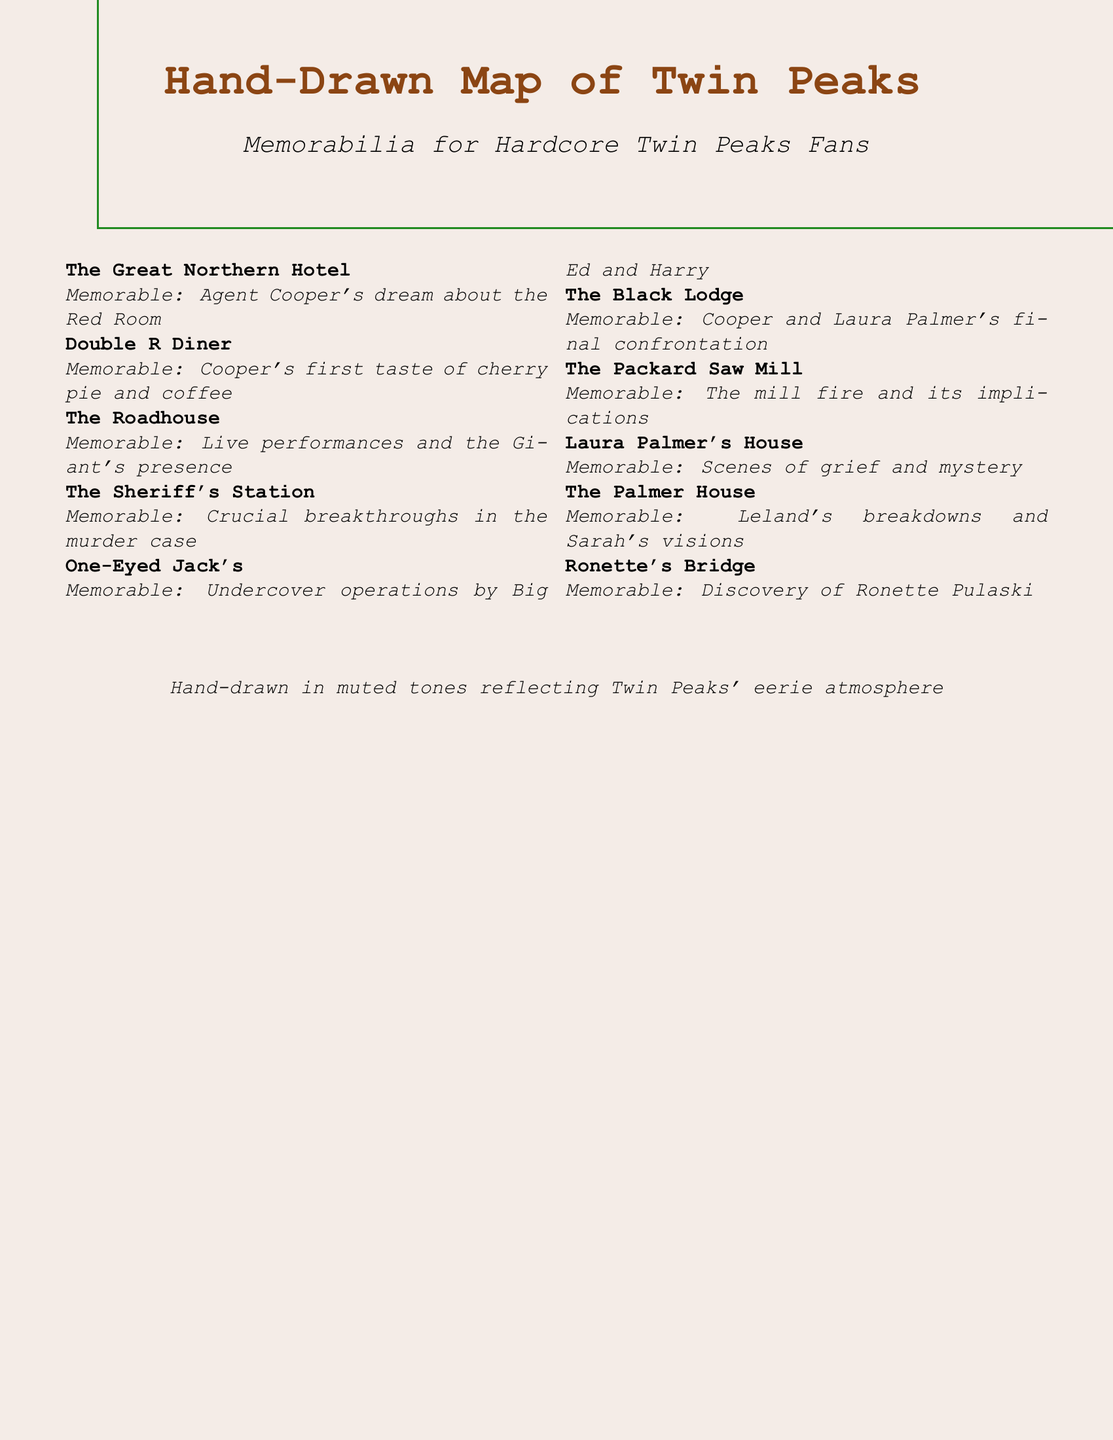What is the memorable scene at The Great Northern Hotel? The memorable scene at The Great Northern Hotel is Agent Cooper's dream about the Red Room.
Answer: Agent Cooper's dream about the Red Room What does Cooper first taste at the Double R Diner? The document states that Cooper's first taste at the Double R Diner was cherry pie and coffee.
Answer: Cherry pie and coffee Which location is associated with crucial breakthroughs in the murder case? The Sheriff's Station is known for crucial breakthroughs in the murder case.
Answer: The Sheriff's Station What happens at The Black Lodge? The memorable scene at The Black Lodge is Cooper and Laura Palmer's final confrontation.
Answer: Cooper and Laura Palmer's final confrontation What is the significance of Ronette's Bridge? At Ronette's Bridge, the discovery of Ronette Pulaski is a notable event.
Answer: Discovery of Ronette Pulaski How many key locations are listed in the document? There are ten key locations mentioned in the document regarding Twin Peaks.
Answer: Ten What color is used for the border of the document? The border of the document is drawn in a shade of green.
Answer: Green What type of art style is the map described in? The map is described as being hand-drawn in muted tones.
Answer: Hand-drawn in muted tones What major event does The Packard Saw Mill represent? The Packard Saw Mill represents the mill fire and its implications.
Answer: The mill fire and its implications Which character's operations are highlighted at One-Eyed Jack's? Big Ed and Harry's undercover operations are highlighted at One-Eyed Jack's.
Answer: Big Ed and Harry 